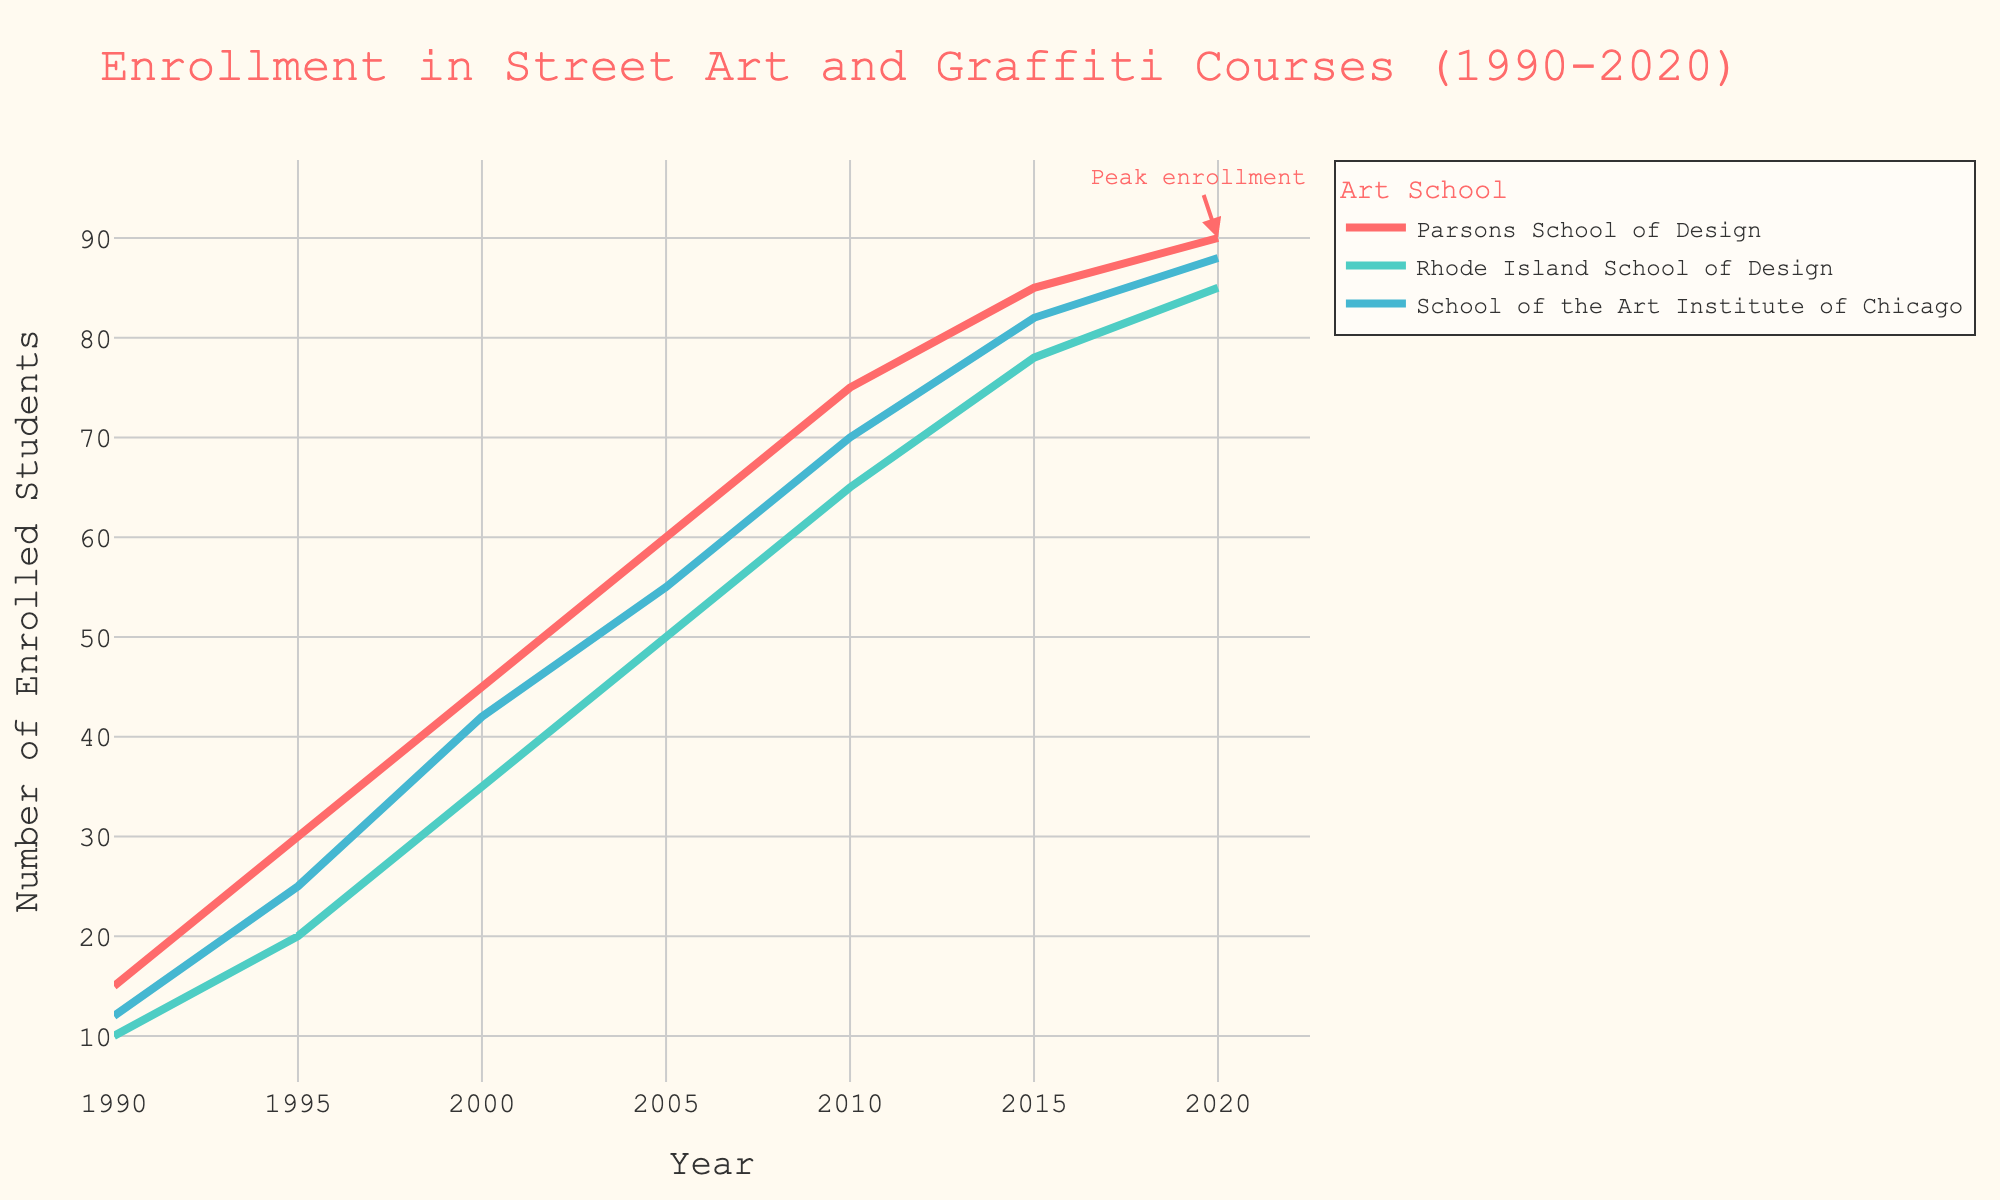What is the title of the plot? The title of the plot is displayed at the top and provides the main topic of the visualized data. It reads "Enrollment in Street Art and Graffiti Courses (1990-2020)."
Answer: Enrollment in Street Art and Graffiti Courses (1990-2020) Which art school had the highest number of enrolled students in 2005? Look at the data points corresponding to the year 2005 on the x-axis and compare the y-values for all three schools. The School of the Art Institute of Chicago had the highest number with 55 students.
Answer: School of the Art Institute of Chicago How does the enrollment trend at Parsons School of Design change from 1990 to 2020? Examine the line representing Parsons School of Design from 1990 to 2020. The line shows a continuous increase in enrollment numbers over time.
Answer: Continuous increase What color represents Rhode Island School of Design in the plot? Identify the line's color in the legend that corresponds to Rhode Island School of Design. It is represented by a turquoise color.
Answer: Turquoise By how much did the number of students at Rhode Island School of Design increase from 1995 to 2005? Subtract the enrollment number in 1995 (20) from that in 2005 (50): 50 - 20 = 30.
Answer: 30 Which year shows a peak enrollment annotation in the plot? Look for the annotation text "Peak enrollment" on the plot. It points to the year 2020.
Answer: 2020 Which art school shows the most consistent growth in student enrollment over the period? Compare the consistency of the slopes of all lines. The line representing Parsons School of Design shows steady and consistent growth.
Answer: Parsons School of Design What is the difference in the number of students between Rhode Island School of Design and School of the Art Institute of Chicago in 2015? Look at the enrollment numbers for both schools in 2015: 82 (School of the Art Institute of Chicago) - 78 (Rhode Island School of Design) = 4.
Answer: 4 Between which two consecutive years did Parsons School of Design show the highest increase in student enrollment? Calculate the differences for each consecutive pair of years for Parsons School of Design: 2000 (45) to 2005 (60) shows the highest increase, 60 - 45 = 15.
Answer: 2000 to 2005 What trends do all three schools share from 1990 to 2020? All three lines indicate an overall increasing trend in student enrollments in street art and graffiti-related courses from 1990 to 2020.
Answer: Increasing enrollment trend 